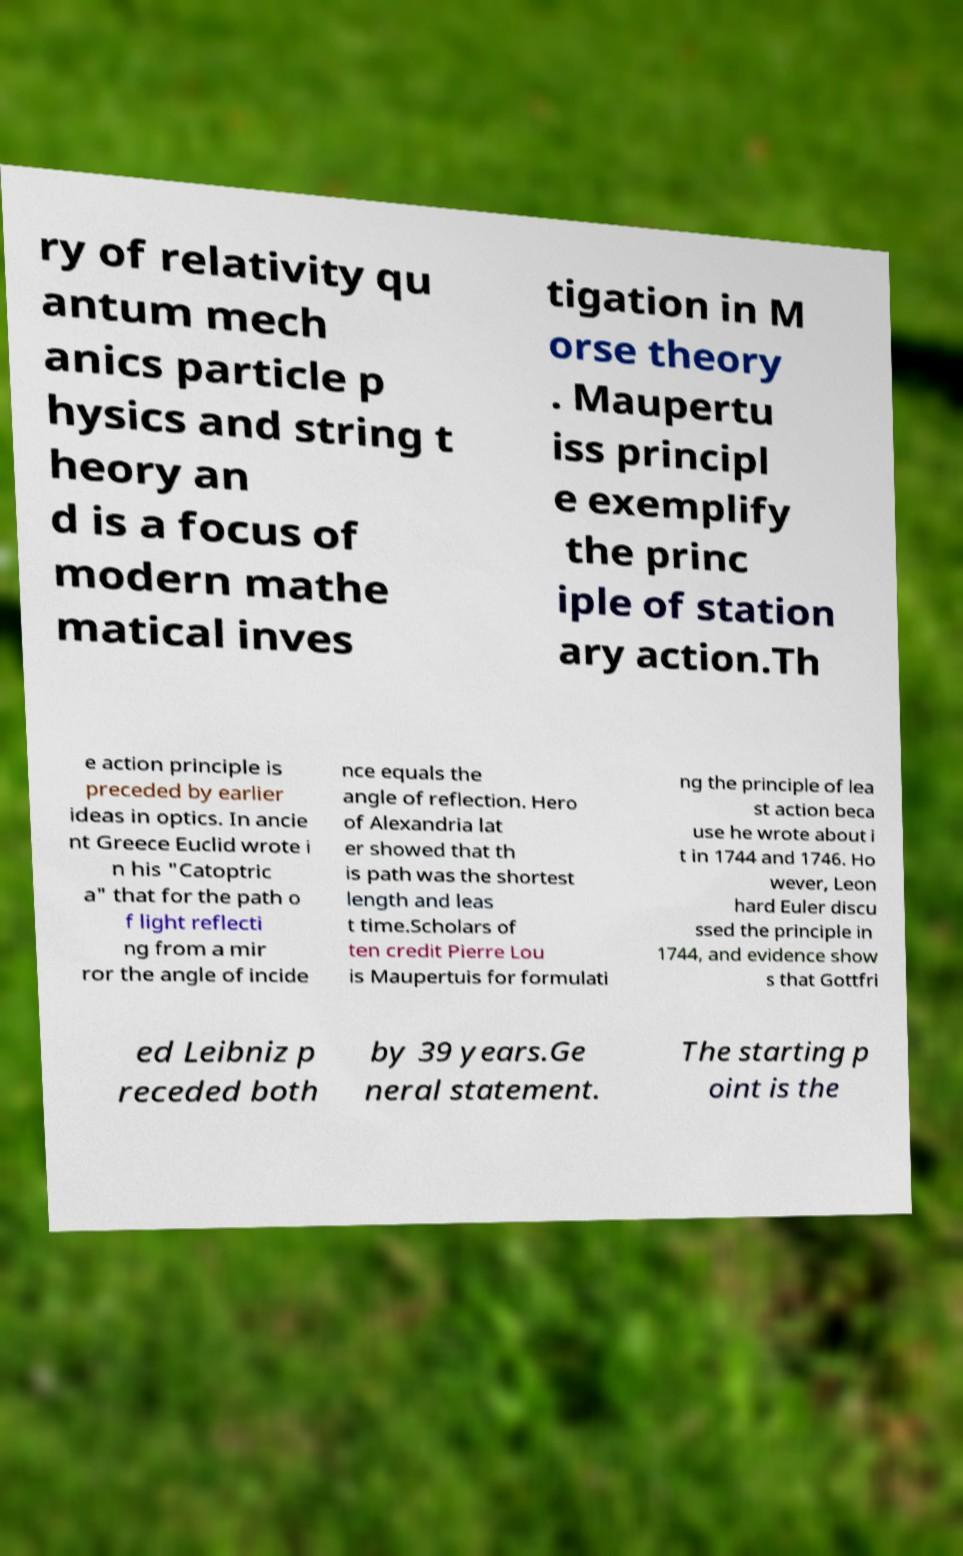Please read and relay the text visible in this image. What does it say? ry of relativity qu antum mech anics particle p hysics and string t heory an d is a focus of modern mathe matical inves tigation in M orse theory . Maupertu iss principl e exemplify the princ iple of station ary action.Th e action principle is preceded by earlier ideas in optics. In ancie nt Greece Euclid wrote i n his "Catoptric a" that for the path o f light reflecti ng from a mir ror the angle of incide nce equals the angle of reflection. Hero of Alexandria lat er showed that th is path was the shortest length and leas t time.Scholars of ten credit Pierre Lou is Maupertuis for formulati ng the principle of lea st action beca use he wrote about i t in 1744 and 1746. Ho wever, Leon hard Euler discu ssed the principle in 1744, and evidence show s that Gottfri ed Leibniz p receded both by 39 years.Ge neral statement. The starting p oint is the 